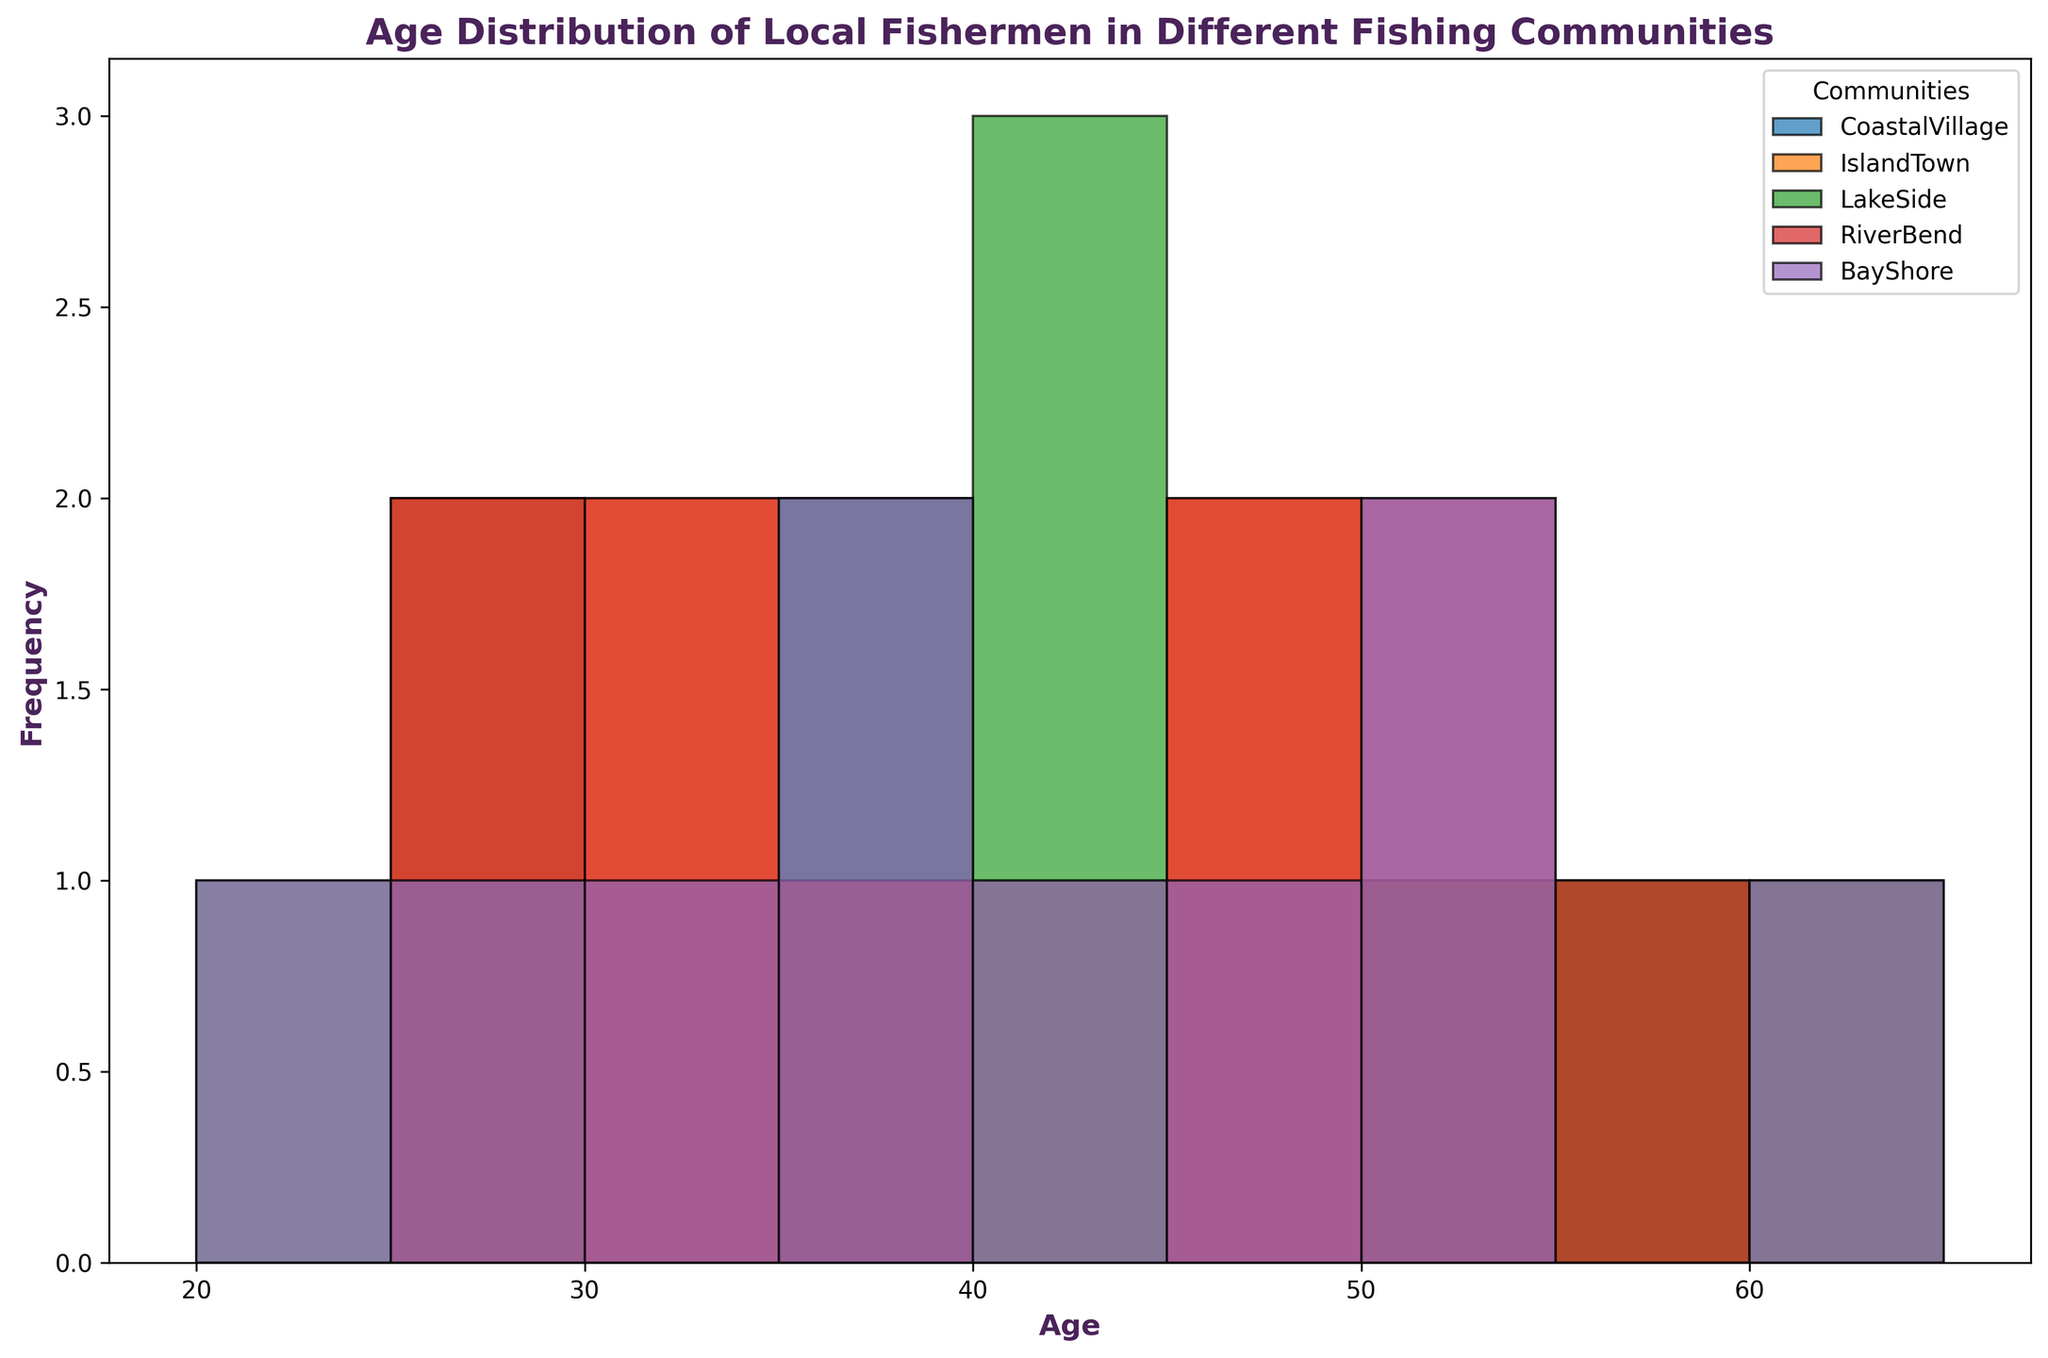Which community has the highest peak in the histogram? By observing the height of the bars in the histogram, we can identify that the IslandTown community has the tallest bar, indicating the highest peak.
Answer: IslandTown Which age group has the highest number of fishermen for the CoastalVillage community? By examining the histogram and identifying the age group bar with the highest frequency specifically for CoastalVillage, the age group 30-35 has the tallest bar.
Answer: 30-35 Compare the age distributions of RiverBend and BayShore. Which community has a wider age range? Looking at the extremes of the age ranges in the histogram, RiverBend's ages spread from 26 to 59, while BayShore's ages range from 23 to 62. Thus, BayShore has a slightly wider age range.
Answer: BayShore How does the frequency of fishermen aged 50-55 compare between LakeSide and RiverBend? Observing the height of the bars corresponding to the age group 50-55, the LakeSide community has a noticeably taller bar compared to the RiverBend community.
Answer: LakeSide What's the average age of fishermen in the IslandTown community? To find the average, we sum the ages of the IslandTown fishermen (27, 33, 49, 54, 61, 42, 31, 29, 55, 47) and divide by the number of data points (which is 10). (27+33+49+54+61+42+31+29+55+47) / 10 = 428 / 10 = 42.8
Answer: 42.8 What age group has the lowest representation across all communities? By identifying the shortest bar across all histograms, we see that the age group 20-25 has the fewest fishermen as it's almost non-existent.
Answer: 20-25 Which community has the most evenly distributed age range? By examining the histogram and comparing the frequency spread across the different age groups for each community, the IslandTown community appears most evenly distributed as there is no significant drop or spike in any one age group.
Answer: IslandTown 